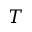Convert formula to latex. <formula><loc_0><loc_0><loc_500><loc_500>T</formula> 